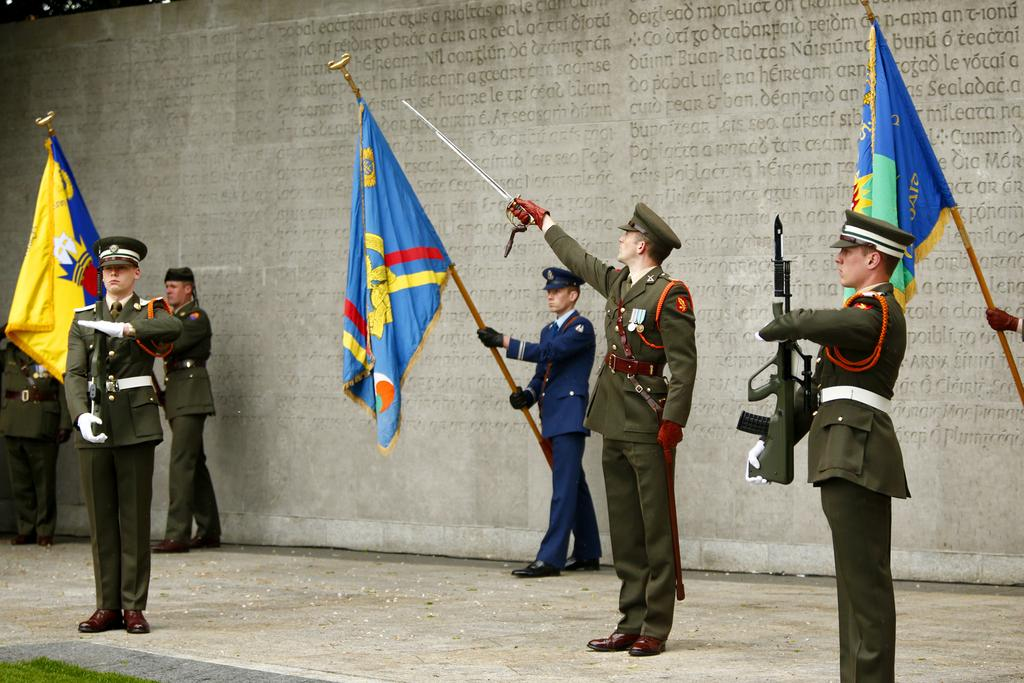What is happening in the middle of the image? There are people standing in the middle of the image. What are the people holding in their hands? The people are holding weapons and swords. Are there any other objects or symbols being held by the people? Yes, the people are also holding flags. What can be seen in the background of the image? There is a wall in the background of the image. How many fowl are perched on the wall in the image? There are no fowl present in the image. What type of box can be seen near the people holding weapons? There is no box visible in the image. 